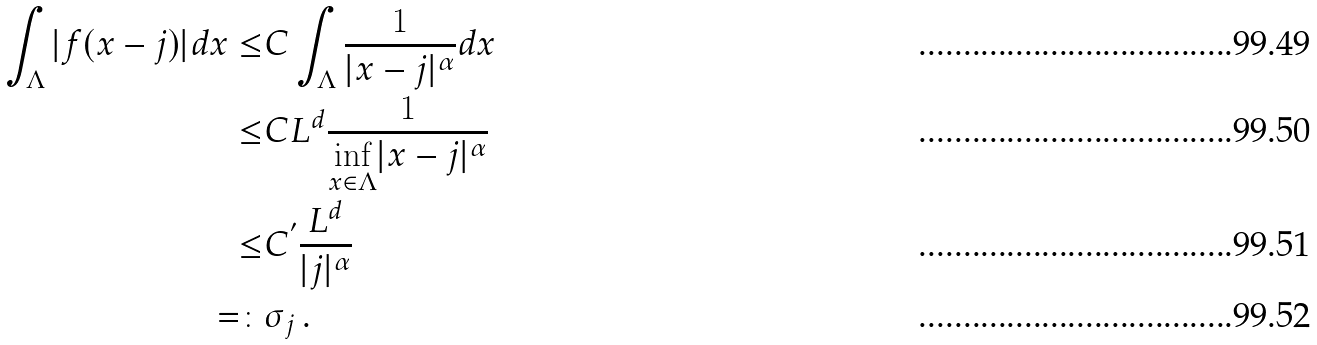<formula> <loc_0><loc_0><loc_500><loc_500>\int _ { \Lambda } | f ( x - j ) | d x \leq & C \int _ { \Lambda } \frac { 1 } { | x - j | ^ { \alpha } } d x \\ \leq & C L ^ { d } \frac { 1 } { \underset { x \in \Lambda } { \inf } | x - j | ^ { \alpha } } \\ \leq & C ^ { ^ { \prime } } \frac { L ^ { d } } { | j | ^ { \alpha } } \\ = \colon & \sigma _ { j } \, .</formula> 